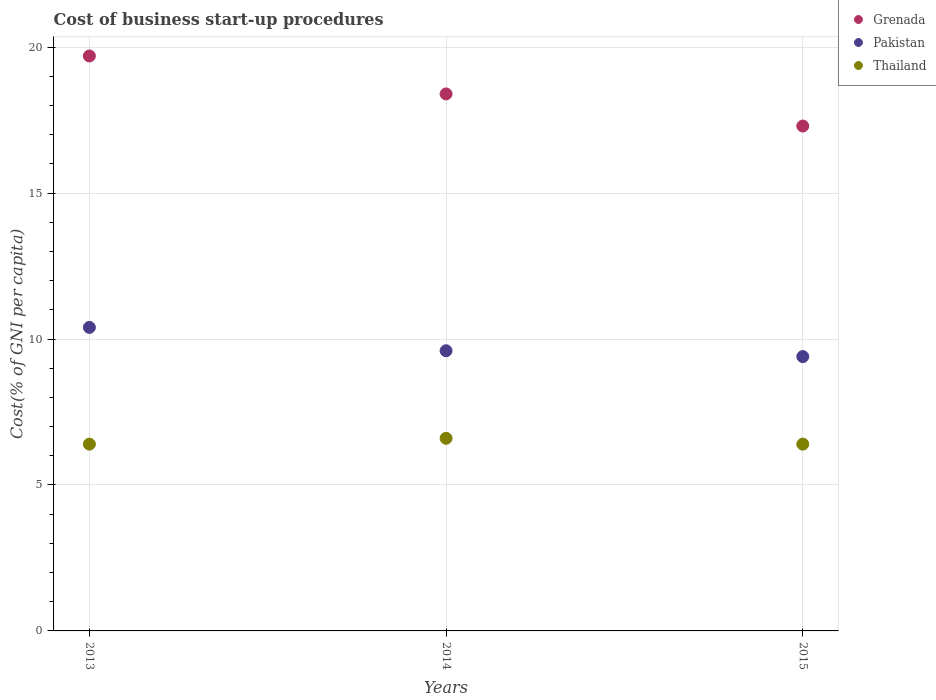How many different coloured dotlines are there?
Provide a succinct answer. 3. Is the number of dotlines equal to the number of legend labels?
Make the answer very short. Yes. In which year was the cost of business start-up procedures in Grenada minimum?
Keep it short and to the point. 2015. What is the total cost of business start-up procedures in Pakistan in the graph?
Keep it short and to the point. 29.4. What is the difference between the cost of business start-up procedures in Thailand in 2013 and that in 2014?
Offer a terse response. -0.2. What is the average cost of business start-up procedures in Pakistan per year?
Ensure brevity in your answer.  9.8. In the year 2013, what is the difference between the cost of business start-up procedures in Grenada and cost of business start-up procedures in Pakistan?
Your response must be concise. 9.3. What is the ratio of the cost of business start-up procedures in Thailand in 2013 to that in 2014?
Provide a short and direct response. 0.97. Is the cost of business start-up procedures in Thailand in 2013 less than that in 2014?
Your answer should be compact. Yes. What is the difference between the highest and the second highest cost of business start-up procedures in Pakistan?
Provide a succinct answer. 0.8. What is the difference between the highest and the lowest cost of business start-up procedures in Thailand?
Your response must be concise. 0.2. Is it the case that in every year, the sum of the cost of business start-up procedures in Grenada and cost of business start-up procedures in Thailand  is greater than the cost of business start-up procedures in Pakistan?
Give a very brief answer. Yes. Does the cost of business start-up procedures in Pakistan monotonically increase over the years?
Ensure brevity in your answer.  No. Is the cost of business start-up procedures in Grenada strictly greater than the cost of business start-up procedures in Thailand over the years?
Your answer should be compact. Yes. Is the cost of business start-up procedures in Thailand strictly less than the cost of business start-up procedures in Grenada over the years?
Give a very brief answer. Yes. How many dotlines are there?
Your answer should be very brief. 3. What is the difference between two consecutive major ticks on the Y-axis?
Make the answer very short. 5. How many legend labels are there?
Keep it short and to the point. 3. How are the legend labels stacked?
Provide a succinct answer. Vertical. What is the title of the graph?
Offer a terse response. Cost of business start-up procedures. Does "Trinidad and Tobago" appear as one of the legend labels in the graph?
Keep it short and to the point. No. What is the label or title of the X-axis?
Offer a very short reply. Years. What is the label or title of the Y-axis?
Your answer should be compact. Cost(% of GNI per capita). What is the Cost(% of GNI per capita) of Pakistan in 2013?
Make the answer very short. 10.4. What is the Cost(% of GNI per capita) of Thailand in 2013?
Make the answer very short. 6.4. What is the Cost(% of GNI per capita) of Grenada in 2014?
Your response must be concise. 18.4. What is the Cost(% of GNI per capita) in Pakistan in 2014?
Make the answer very short. 9.6. What is the Cost(% of GNI per capita) of Pakistan in 2015?
Your answer should be very brief. 9.4. What is the Cost(% of GNI per capita) of Thailand in 2015?
Your answer should be very brief. 6.4. Across all years, what is the maximum Cost(% of GNI per capita) of Grenada?
Your answer should be compact. 19.7. Across all years, what is the maximum Cost(% of GNI per capita) of Pakistan?
Provide a short and direct response. 10.4. Across all years, what is the minimum Cost(% of GNI per capita) in Pakistan?
Offer a terse response. 9.4. What is the total Cost(% of GNI per capita) in Grenada in the graph?
Your answer should be compact. 55.4. What is the total Cost(% of GNI per capita) in Pakistan in the graph?
Give a very brief answer. 29.4. What is the total Cost(% of GNI per capita) of Thailand in the graph?
Your answer should be very brief. 19.4. What is the difference between the Cost(% of GNI per capita) of Pakistan in 2013 and that in 2014?
Ensure brevity in your answer.  0.8. What is the difference between the Cost(% of GNI per capita) of Thailand in 2013 and that in 2014?
Your response must be concise. -0.2. What is the difference between the Cost(% of GNI per capita) in Grenada in 2013 and that in 2015?
Provide a succinct answer. 2.4. What is the difference between the Cost(% of GNI per capita) of Grenada in 2014 and that in 2015?
Give a very brief answer. 1.1. What is the difference between the Cost(% of GNI per capita) in Pakistan in 2014 and that in 2015?
Your response must be concise. 0.2. What is the difference between the Cost(% of GNI per capita) of Grenada in 2013 and the Cost(% of GNI per capita) of Pakistan in 2014?
Ensure brevity in your answer.  10.1. What is the difference between the Cost(% of GNI per capita) of Grenada in 2013 and the Cost(% of GNI per capita) of Thailand in 2014?
Provide a short and direct response. 13.1. What is the difference between the Cost(% of GNI per capita) of Pakistan in 2013 and the Cost(% of GNI per capita) of Thailand in 2014?
Offer a very short reply. 3.8. What is the difference between the Cost(% of GNI per capita) in Grenada in 2013 and the Cost(% of GNI per capita) in Pakistan in 2015?
Ensure brevity in your answer.  10.3. What is the difference between the Cost(% of GNI per capita) of Pakistan in 2013 and the Cost(% of GNI per capita) of Thailand in 2015?
Your answer should be compact. 4. What is the difference between the Cost(% of GNI per capita) of Grenada in 2014 and the Cost(% of GNI per capita) of Pakistan in 2015?
Your response must be concise. 9. What is the difference between the Cost(% of GNI per capita) in Grenada in 2014 and the Cost(% of GNI per capita) in Thailand in 2015?
Your answer should be very brief. 12. What is the difference between the Cost(% of GNI per capita) of Pakistan in 2014 and the Cost(% of GNI per capita) of Thailand in 2015?
Offer a terse response. 3.2. What is the average Cost(% of GNI per capita) of Grenada per year?
Ensure brevity in your answer.  18.47. What is the average Cost(% of GNI per capita) in Pakistan per year?
Give a very brief answer. 9.8. What is the average Cost(% of GNI per capita) of Thailand per year?
Keep it short and to the point. 6.47. In the year 2013, what is the difference between the Cost(% of GNI per capita) of Grenada and Cost(% of GNI per capita) of Thailand?
Keep it short and to the point. 13.3. In the year 2013, what is the difference between the Cost(% of GNI per capita) of Pakistan and Cost(% of GNI per capita) of Thailand?
Ensure brevity in your answer.  4. In the year 2014, what is the difference between the Cost(% of GNI per capita) of Pakistan and Cost(% of GNI per capita) of Thailand?
Your answer should be very brief. 3. In the year 2015, what is the difference between the Cost(% of GNI per capita) in Grenada and Cost(% of GNI per capita) in Pakistan?
Make the answer very short. 7.9. In the year 2015, what is the difference between the Cost(% of GNI per capita) in Pakistan and Cost(% of GNI per capita) in Thailand?
Make the answer very short. 3. What is the ratio of the Cost(% of GNI per capita) of Grenada in 2013 to that in 2014?
Make the answer very short. 1.07. What is the ratio of the Cost(% of GNI per capita) of Pakistan in 2013 to that in 2014?
Ensure brevity in your answer.  1.08. What is the ratio of the Cost(% of GNI per capita) in Thailand in 2013 to that in 2014?
Offer a terse response. 0.97. What is the ratio of the Cost(% of GNI per capita) of Grenada in 2013 to that in 2015?
Keep it short and to the point. 1.14. What is the ratio of the Cost(% of GNI per capita) in Pakistan in 2013 to that in 2015?
Offer a terse response. 1.11. What is the ratio of the Cost(% of GNI per capita) in Grenada in 2014 to that in 2015?
Ensure brevity in your answer.  1.06. What is the ratio of the Cost(% of GNI per capita) of Pakistan in 2014 to that in 2015?
Your answer should be very brief. 1.02. What is the ratio of the Cost(% of GNI per capita) of Thailand in 2014 to that in 2015?
Provide a succinct answer. 1.03. What is the difference between the highest and the second highest Cost(% of GNI per capita) in Pakistan?
Your answer should be very brief. 0.8. What is the difference between the highest and the second highest Cost(% of GNI per capita) of Thailand?
Keep it short and to the point. 0.2. What is the difference between the highest and the lowest Cost(% of GNI per capita) of Grenada?
Provide a short and direct response. 2.4. What is the difference between the highest and the lowest Cost(% of GNI per capita) of Pakistan?
Your answer should be compact. 1. 